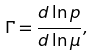Convert formula to latex. <formula><loc_0><loc_0><loc_500><loc_500>\Gamma = \frac { d \ln p } { d \ln \mu } ,</formula> 